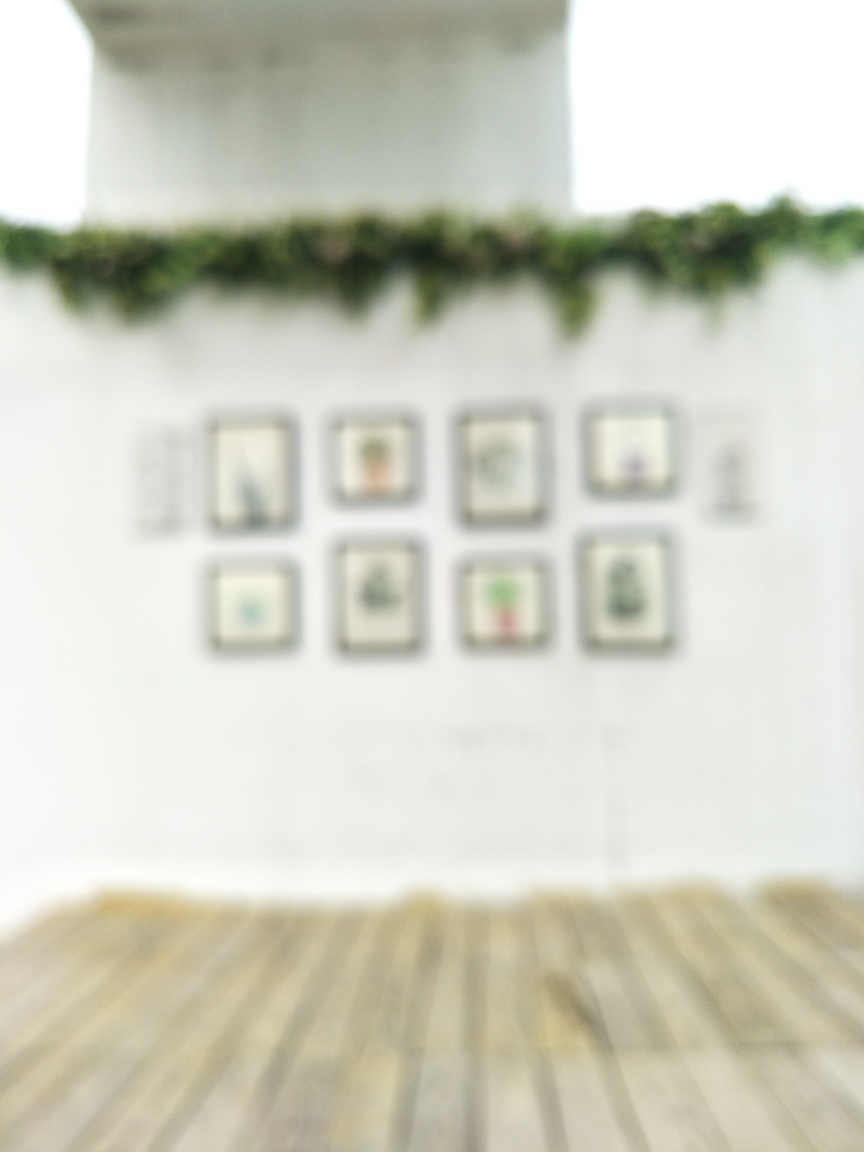Considering the content seems to be framed artworks, what could be the purpose of presenting them in such a blurred state? Presenting framed artworks in a blurred state could be an artistic choice meant to provoke thought or stir curiosity about the obscured subjects. It might encourage viewers to imagine what's hidden, focus on the emotion conveyed through the blur, or critique the boundaries of traditional art presentation. 